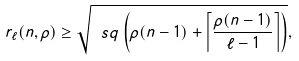<formula> <loc_0><loc_0><loc_500><loc_500>r _ { \ell } ( n , \rho ) \geq \sqrt { \ s q \left ( \rho ( n - 1 ) + \left \lceil \frac { \rho ( n - 1 ) } { \ell - 1 } \right \rceil \right ) } ,</formula> 